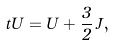<formula> <loc_0><loc_0><loc_500><loc_500>\ t { U } = U + \frac { 3 } { 2 } \, J ,</formula> 